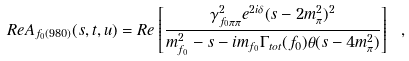Convert formula to latex. <formula><loc_0><loc_0><loc_500><loc_500>R e A _ { f _ { 0 } ( 9 8 0 ) } ( s , t , u ) = R e \left [ \frac { \gamma _ { f _ { 0 } \pi \pi } ^ { 2 } e ^ { 2 i \delta } ( s - 2 m _ { \pi } ^ { 2 } ) ^ { 2 } } { m _ { f _ { 0 } } ^ { 2 } - s - i m _ { f _ { 0 } } \Gamma _ { t o t } ( f _ { 0 } ) \theta ( s - 4 m _ { \pi } ^ { 2 } ) } \right ] \ ,</formula> 